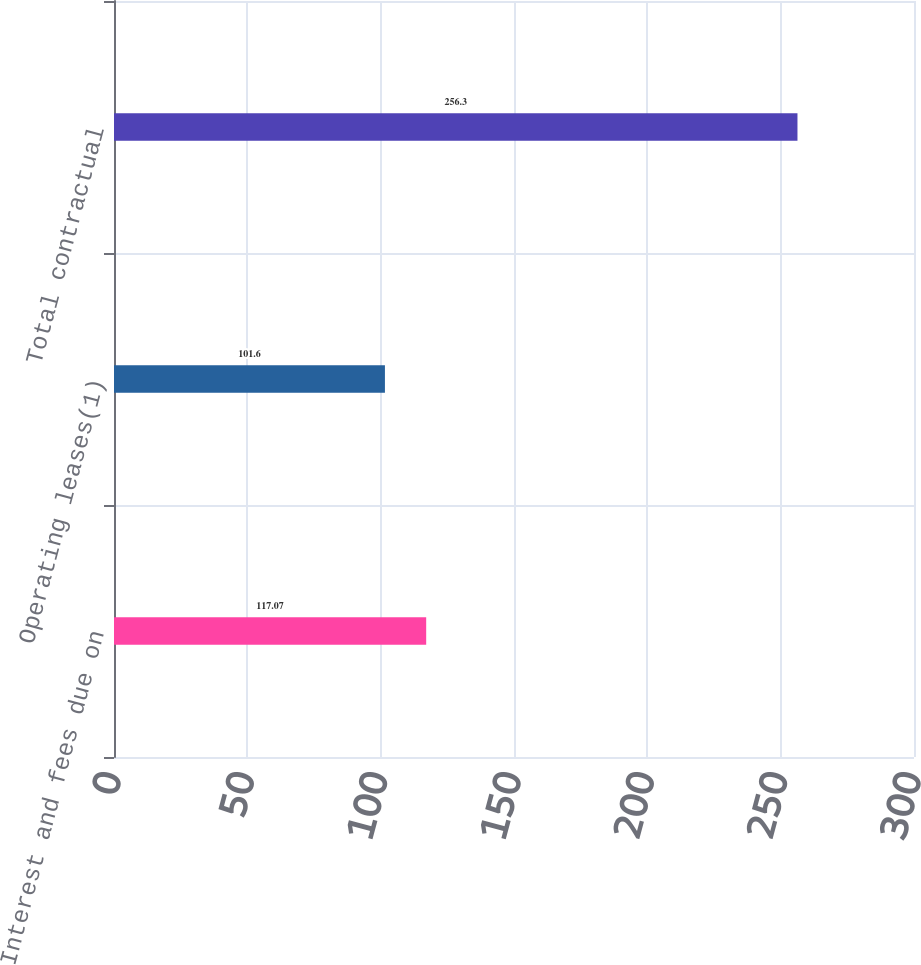<chart> <loc_0><loc_0><loc_500><loc_500><bar_chart><fcel>Interest and fees due on<fcel>Operating leases(1)<fcel>Total contractual<nl><fcel>117.07<fcel>101.6<fcel>256.3<nl></chart> 